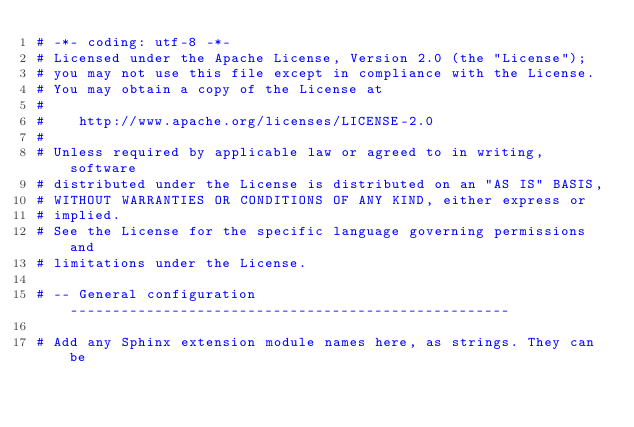Convert code to text. <code><loc_0><loc_0><loc_500><loc_500><_Python_># -*- coding: utf-8 -*-
# Licensed under the Apache License, Version 2.0 (the "License");
# you may not use this file except in compliance with the License.
# You may obtain a copy of the License at
#
#    http://www.apache.org/licenses/LICENSE-2.0
#
# Unless required by applicable law or agreed to in writing, software
# distributed under the License is distributed on an "AS IS" BASIS,
# WITHOUT WARRANTIES OR CONDITIONS OF ANY KIND, either express or
# implied.
# See the License for the specific language governing permissions and
# limitations under the License.

# -- General configuration ----------------------------------------------------

# Add any Sphinx extension module names here, as strings. They can be</code> 